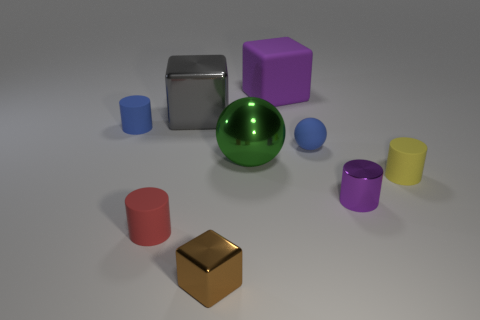There is a tiny thing left of the red matte object; what is its material?
Provide a short and direct response. Rubber. Is the material of the tiny blue thing left of the small blue ball the same as the gray thing?
Keep it short and to the point. No. Are there any small things?
Provide a short and direct response. Yes. There is a big thing that is made of the same material as the blue sphere; what is its color?
Offer a terse response. Purple. What color is the matte cylinder behind the small yellow rubber cylinder that is in front of the tiny blue object to the right of the tiny brown metallic thing?
Keep it short and to the point. Blue. There is a red object; is its size the same as the ball on the right side of the large rubber object?
Offer a terse response. Yes. How many objects are metallic things that are on the right side of the tiny brown block or tiny things to the right of the purple shiny object?
Give a very brief answer. 3. What shape is the yellow object that is the same size as the red cylinder?
Give a very brief answer. Cylinder. There is a small blue thing that is left of the blue matte thing on the right side of the cube that is in front of the tiny blue cylinder; what is its shape?
Your response must be concise. Cylinder. Is the number of red rubber objects that are to the left of the blue cylinder the same as the number of large metallic balls?
Your answer should be very brief. No. 